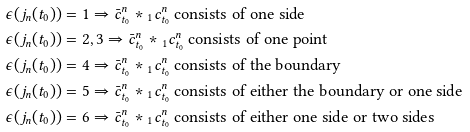<formula> <loc_0><loc_0><loc_500><loc_500>\epsilon ( j _ { n } ( t _ { 0 } ) ) & = 1 \Rightarrow \bar { c } ^ { n } _ { t _ { 0 } } * { _ { 1 } c ^ { n } _ { t _ { 0 } } } \text { consists of one side} \\ \epsilon ( j _ { n } ( t _ { 0 } ) ) & = 2 , 3 \Rightarrow \bar { c } ^ { n } _ { t _ { 0 } } * { _ { 1 } c ^ { n } _ { t _ { 0 } } } \text { consists of one point} \\ \epsilon ( j _ { n } ( t _ { 0 } ) ) & = 4 \Rightarrow \bar { c } ^ { n } _ { t _ { 0 } } * { _ { 1 } c ^ { n } _ { t _ { 0 } } } \text { consists of the boundary} \\ \epsilon ( j _ { n } ( t _ { 0 } ) ) & = 5 \Rightarrow \bar { c } ^ { n } _ { t _ { 0 } } * { _ { 1 } c ^ { n } _ { t _ { 0 } } } \text { consists of either the boundary or one side} \\ \epsilon ( j _ { n } ( t _ { 0 } ) ) & = 6 \Rightarrow \bar { c } ^ { n } _ { t _ { 0 } } * { _ { 1 } c ^ { n } _ { t _ { 0 } } } \text { consists of either one side or two sides}</formula> 